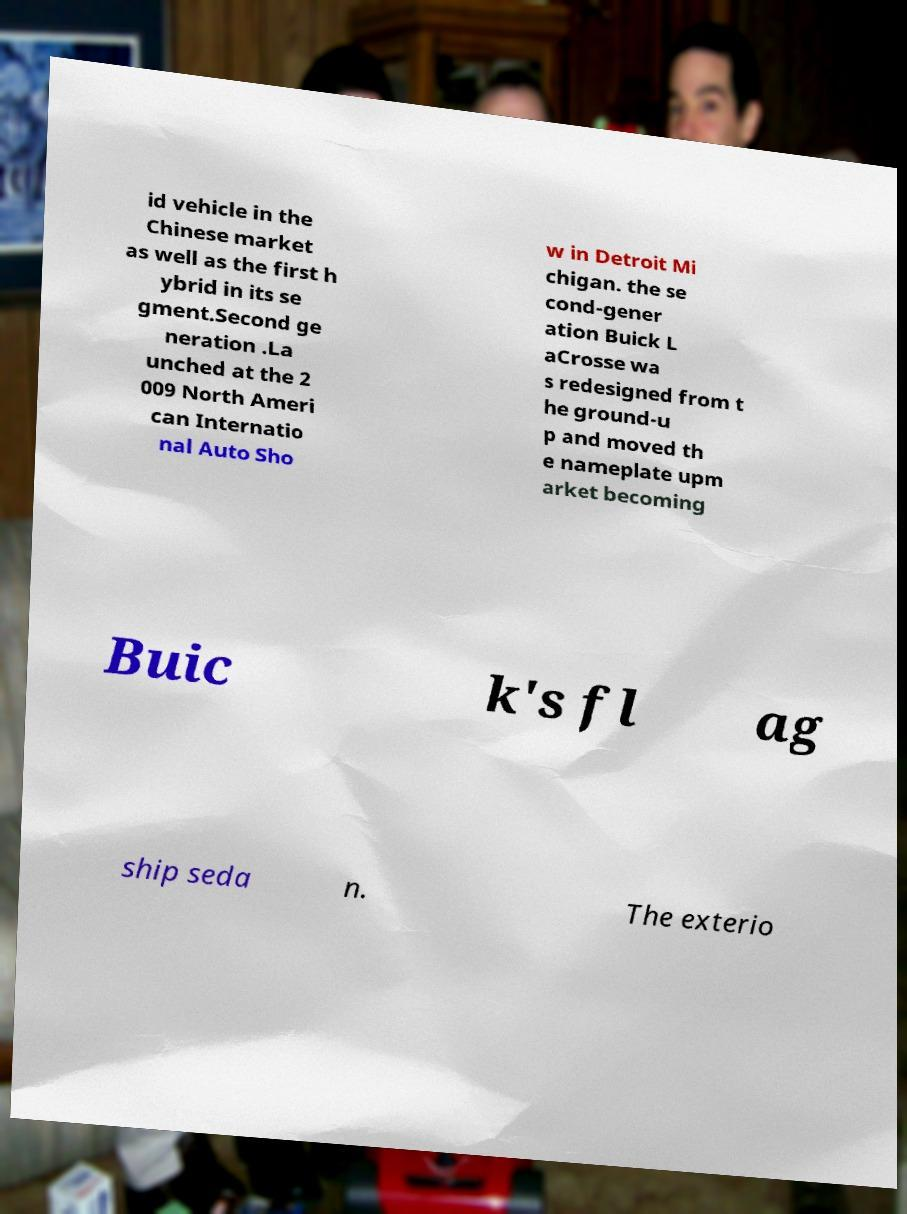Could you assist in decoding the text presented in this image and type it out clearly? id vehicle in the Chinese market as well as the first h ybrid in its se gment.Second ge neration .La unched at the 2 009 North Ameri can Internatio nal Auto Sho w in Detroit Mi chigan. the se cond-gener ation Buick L aCrosse wa s redesigned from t he ground-u p and moved th e nameplate upm arket becoming Buic k's fl ag ship seda n. The exterio 